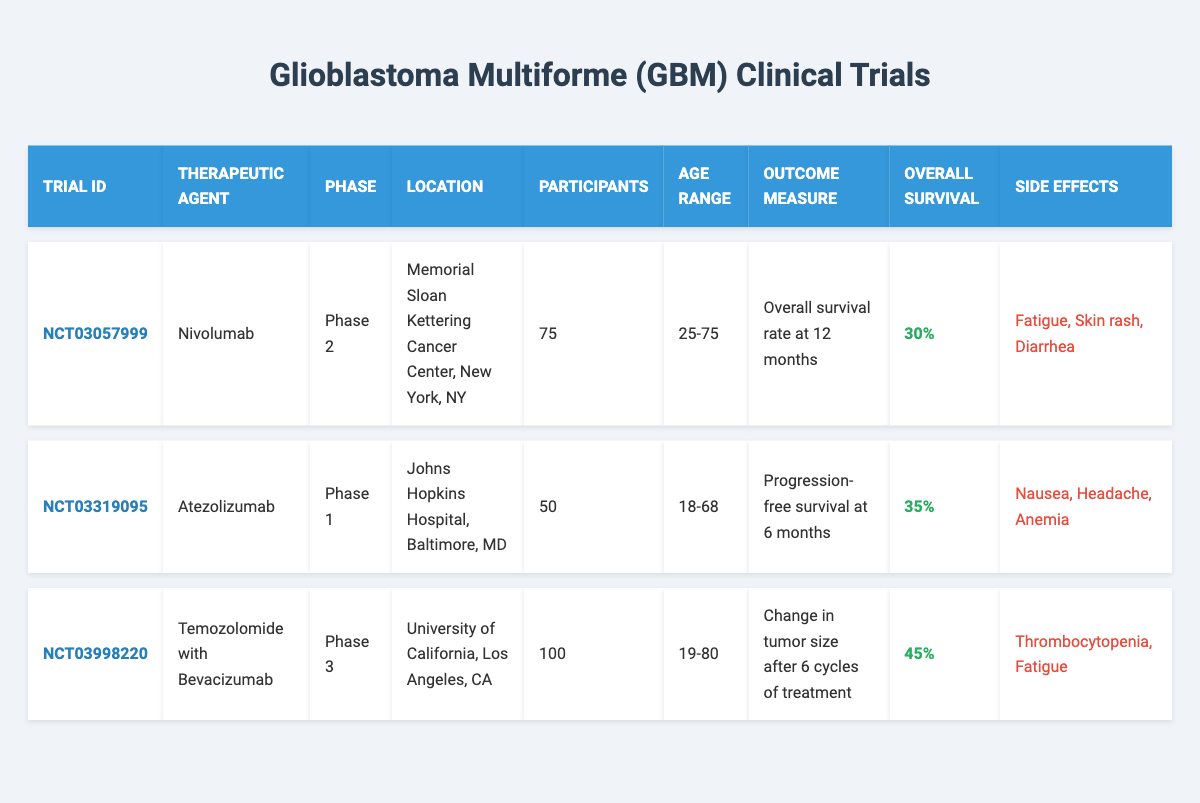What is the location of the trial with ID NCT03057999? The table lists the trial locations alongside each trial ID. For NCT03057999, it shows that the location is "Memorial Sloan Kettering Cancer Center, New York, NY."
Answer: Memorial Sloan Kettering Cancer Center, New York, NY How many participants were there in the trial for Atezolizumab? Looking at the row for Atezolizumab, you can see that the number of participants is stated as 50.
Answer: 50 What is the overall survival rate for the Temozolomide with Bevacizumab trial? In the row for Temozolomide with Bevacizumab, the overall survival rate is presented, which is 45%.
Answer: 45% What is the age range of participants in the Nivolumab trial? The age range for the Nivolumab trial is provided in the table, showing a minimum age of 25 and a maximum age of 75, which can be summarized as 25-75.
Answer: 25-75 Which trial has the highest number of participants? By comparing the participant counts in each trial, Temozolomide with Bevacizumab has the most at 100 participants, compared to 75 for Nivolumab and 50 for Atezolizumab.
Answer: 100 Does the trial for Atezolizumab include more males or females? From the gender distribution data of the Atezolizumab trial, there are 30 males and 20 females. Since there are more males, the answer is yes.
Answer: Yes What is the combined number of male participants across all trials? Adding the male participants from each trial gives: 45 (Nivolumab) + 30 (Atezolizumab) + 55 (Temozolomide with Bevacizumab) = 130.
Answer: 130 What is the side effect that appears in both the Nivolumab and Temozolomide with Bevacizumab trials? By looking through the side effects listed for both trials, "Fatigue" is present in both.
Answer: Fatigue Is the outcome measure for the Atezolizumab trial directly related to overall survival? The Atezolizumab trial has an outcome measure of "Progression-free survival at 6 months," which is not the same as overall survival, hence the answer is no.
Answer: No What percentage of participants in the Nivolumab trial had an ECOG performance status of 1? There are 40 participants with an ECOG performance status of 1 out of 75 total participants. To calculate the percentage: (40 / 75) * 100 = 53.33%.
Answer: 53.33% 